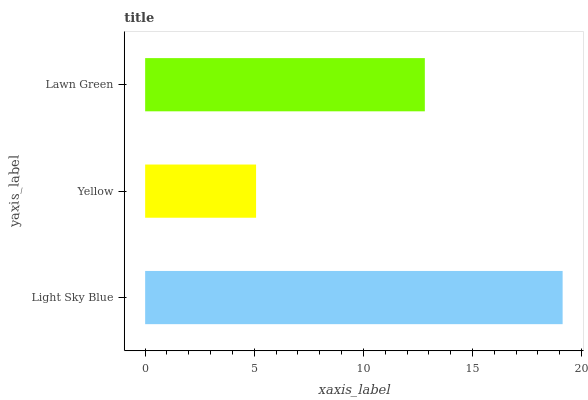Is Yellow the minimum?
Answer yes or no. Yes. Is Light Sky Blue the maximum?
Answer yes or no. Yes. Is Lawn Green the minimum?
Answer yes or no. No. Is Lawn Green the maximum?
Answer yes or no. No. Is Lawn Green greater than Yellow?
Answer yes or no. Yes. Is Yellow less than Lawn Green?
Answer yes or no. Yes. Is Yellow greater than Lawn Green?
Answer yes or no. No. Is Lawn Green less than Yellow?
Answer yes or no. No. Is Lawn Green the high median?
Answer yes or no. Yes. Is Lawn Green the low median?
Answer yes or no. Yes. Is Yellow the high median?
Answer yes or no. No. Is Yellow the low median?
Answer yes or no. No. 